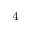<formula> <loc_0><loc_0><loc_500><loc_500>_ { 4 }</formula> 